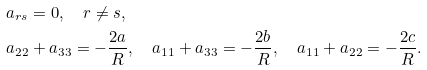Convert formula to latex. <formula><loc_0><loc_0><loc_500><loc_500>& a _ { r s } = 0 , \quad r \not = s , \\ & a _ { 2 2 } + a _ { 3 3 } = - \frac { 2 a } { R } , \quad a _ { 1 1 } + a _ { 3 3 } = - \frac { 2 b } { R } , \quad a _ { 1 1 } + a _ { 2 2 } = - \frac { 2 c } { R } .</formula> 